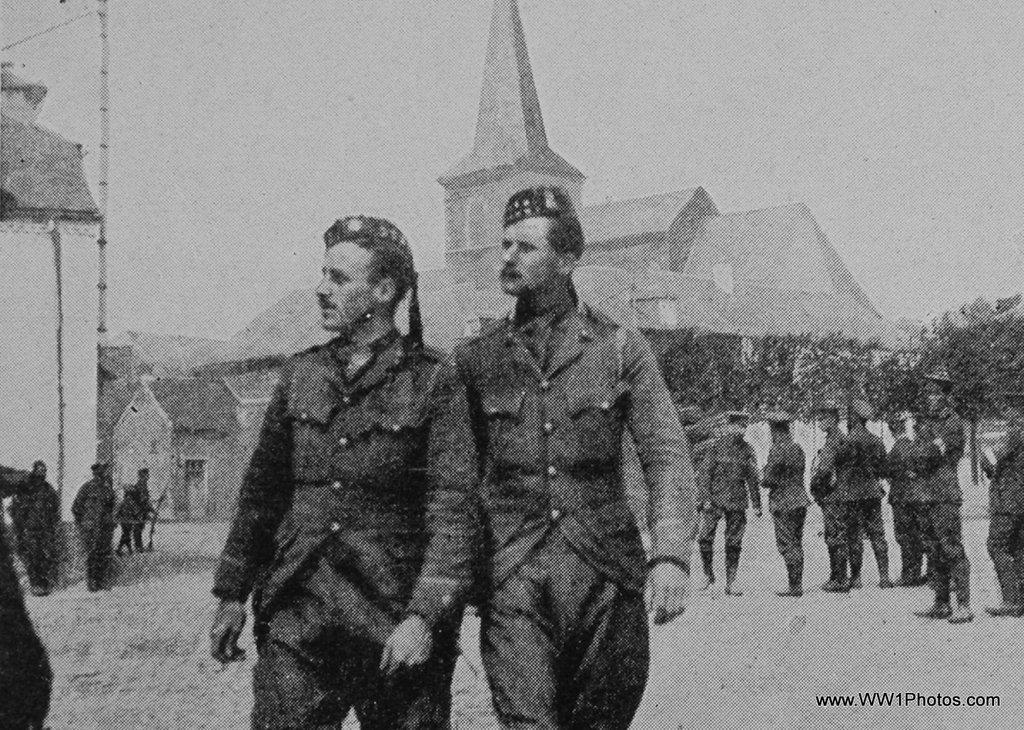Could you give a brief overview of what you see in this image? Here this is a black and white image in which, in the front we can see two men standing with uniform and cap on them and behind them also we can see other number of people standing with uniforms and caps and some of them are holding guns in their hands and we can also see other buildings also present and we can see plants and trees also present. 